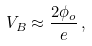<formula> <loc_0><loc_0><loc_500><loc_500>V _ { B } \approx \frac { 2 \phi _ { o } } { e } \, ,</formula> 